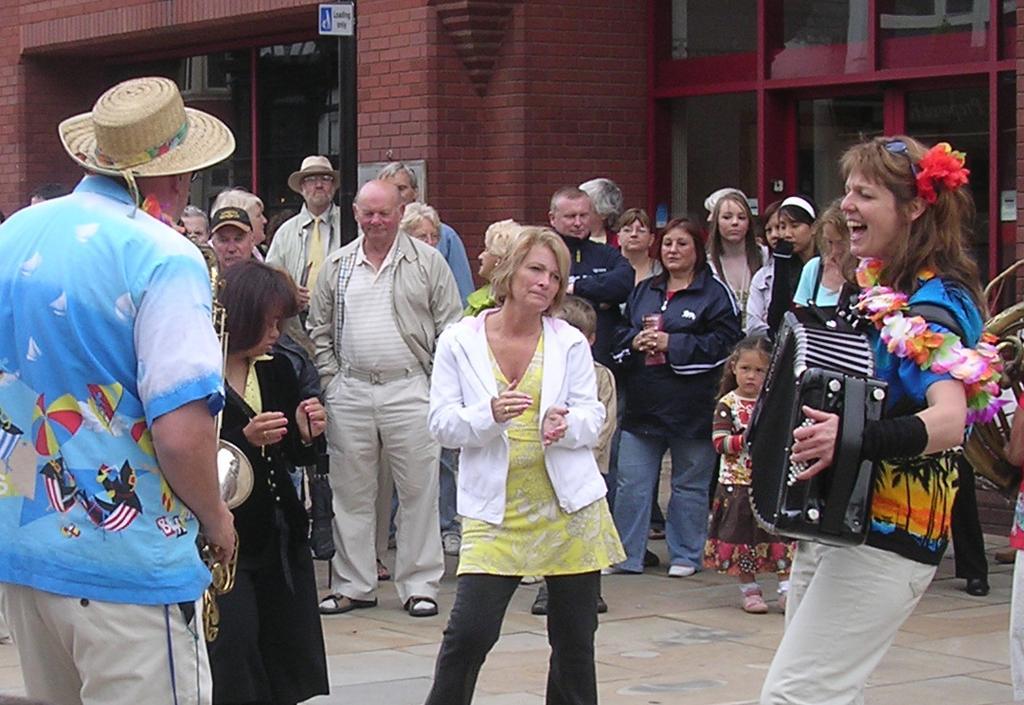Please provide a concise description of this image. This image is taken in outdoors. There are many people in this image standing on the road. In the left side of the image a man, wearing a hat and standing on the road. In the middle of the image a woman is performing along with two woman beside her. In the right side of the image a woman is playing the music with a musical instrument. In the background there is a wall with windows and doors. 